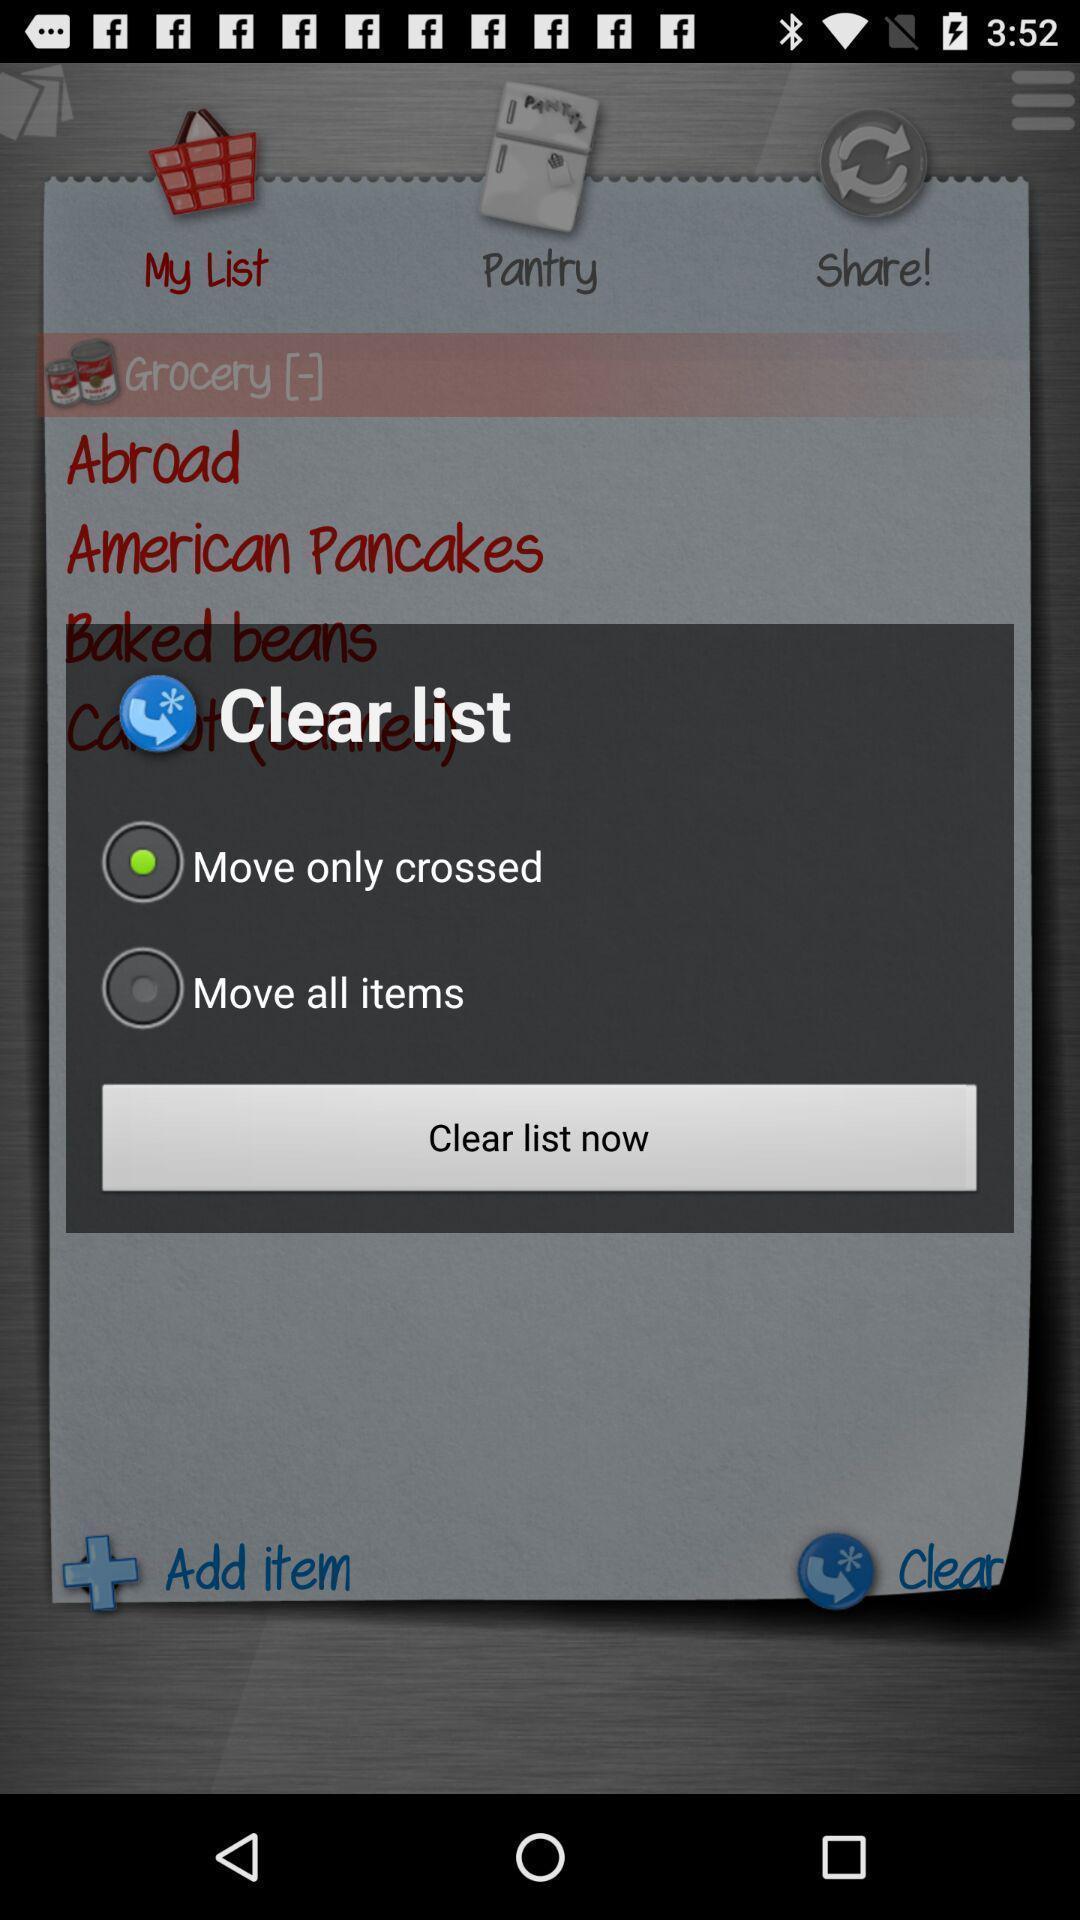What details can you identify in this image? Pop-up with options to clear list. 